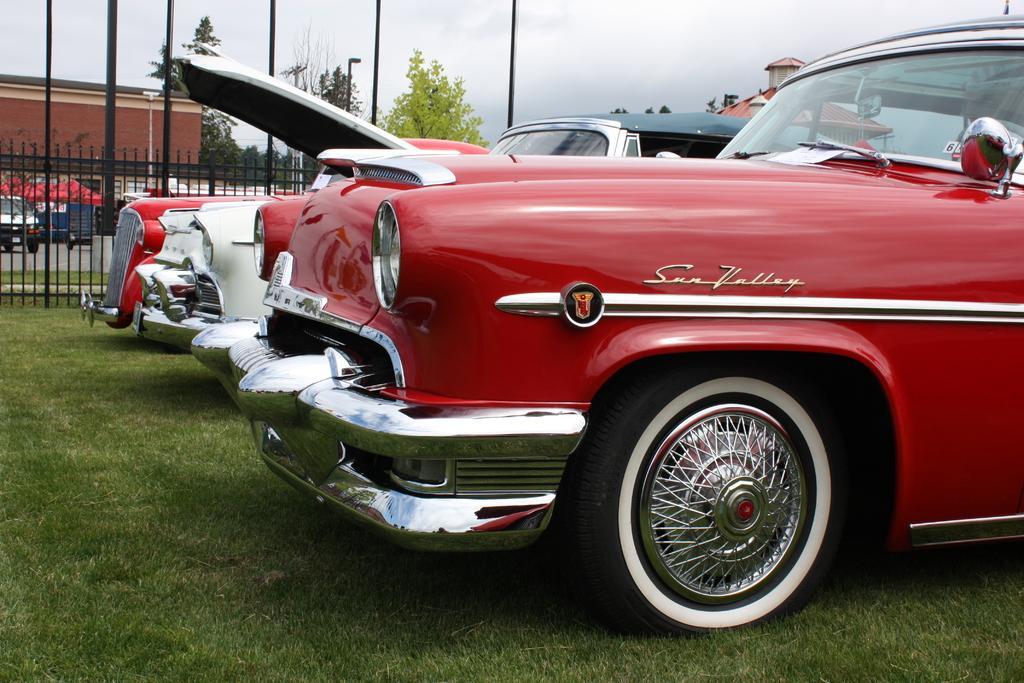Could you give a brief overview of what you see in this image? In this picture I can see the cars which parked on the grass. In the background I can see the building, shed, poles, street lights, trees, plants, vehicles and other objects. At the top I can see the sky and clouds. 